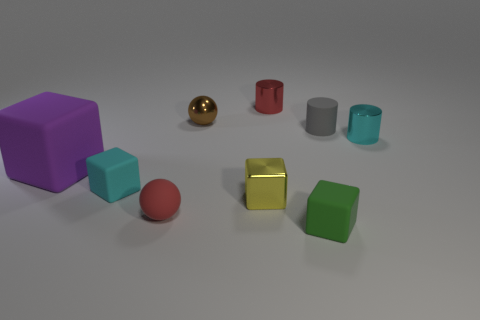What number of other objects are the same shape as the green rubber thing?
Give a very brief answer. 3. Is there any other thing of the same color as the shiny ball?
Offer a terse response. No. Does the tiny rubber cylinder have the same color as the matte block on the right side of the red shiny object?
Make the answer very short. No. How many other things are there of the same size as the rubber ball?
Your answer should be compact. 7. What size is the metal cylinder that is the same color as the small matte sphere?
Ensure brevity in your answer.  Small. What number of balls are either purple things or small brown shiny things?
Offer a very short reply. 1. There is a metal thing that is on the right side of the green object; is its shape the same as the tiny green matte thing?
Keep it short and to the point. No. Are there more small metal cylinders to the left of the tiny brown sphere than small cyan metallic things?
Your response must be concise. No. The matte ball that is the same size as the gray rubber object is what color?
Keep it short and to the point. Red. What number of things are balls that are in front of the large matte block or brown metal blocks?
Your answer should be very brief. 1. 